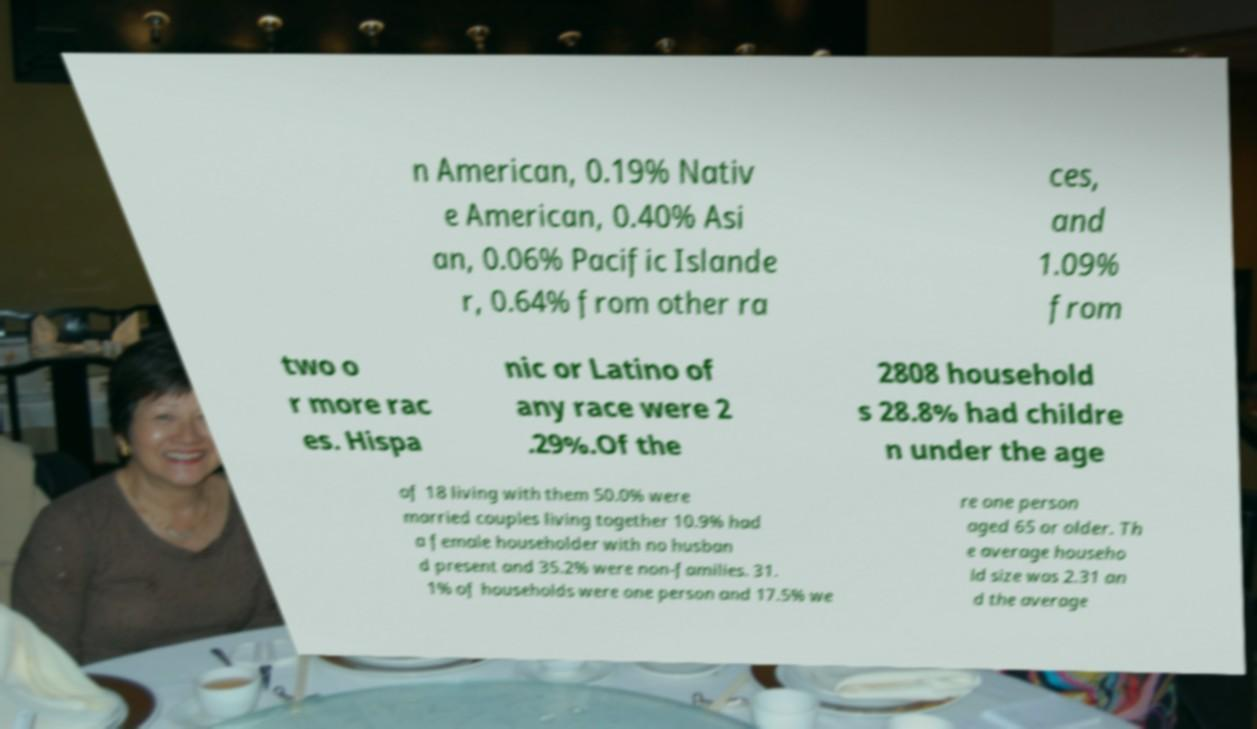Please read and relay the text visible in this image. What does it say? n American, 0.19% Nativ e American, 0.40% Asi an, 0.06% Pacific Islande r, 0.64% from other ra ces, and 1.09% from two o r more rac es. Hispa nic or Latino of any race were 2 .29%.Of the 2808 household s 28.8% had childre n under the age of 18 living with them 50.0% were married couples living together 10.9% had a female householder with no husban d present and 35.2% were non-families. 31. 1% of households were one person and 17.5% we re one person aged 65 or older. Th e average househo ld size was 2.31 an d the average 